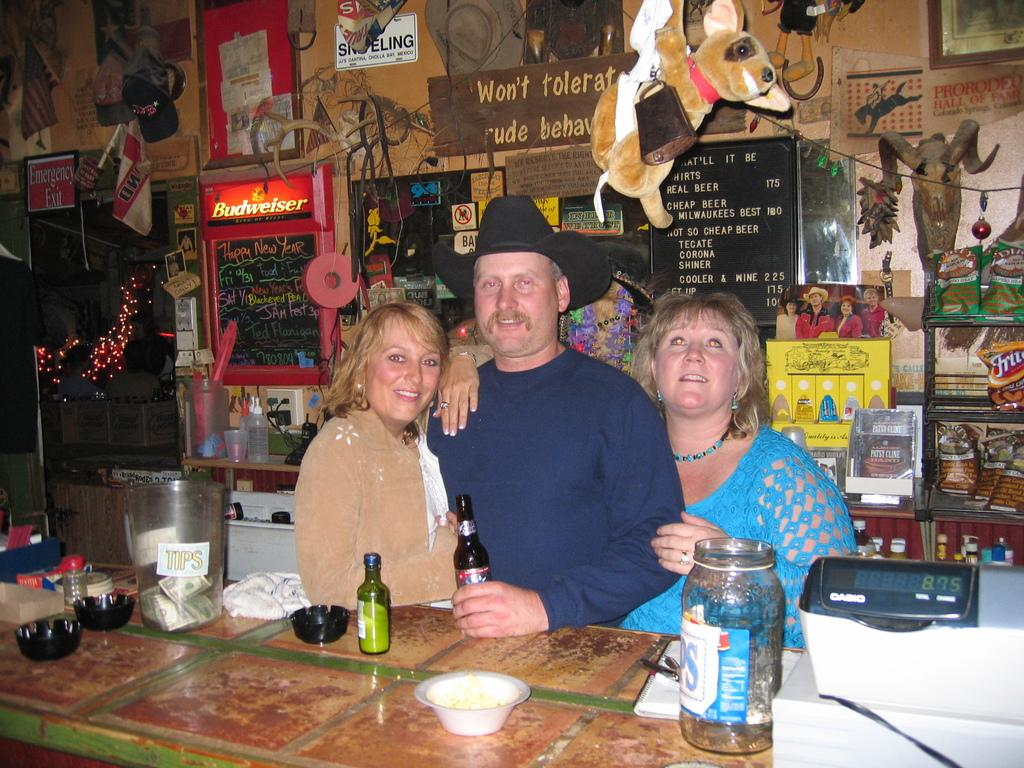How many people are in the image? There are two women and one man in the image. What objects can be seen on the table in the image? There are bottles and bowls on the table in the image. Can you describe anything visible in the background of the image? Yes, there is a soft toy visible in the background of the image. What type of tin can be seen in the image? There is no tin present in the image. How many girls are in the image? The image features two women and one man, but it does not specify their ages or whether they are girls. Can you describe the goose in the image? There is no goose present in the image. 